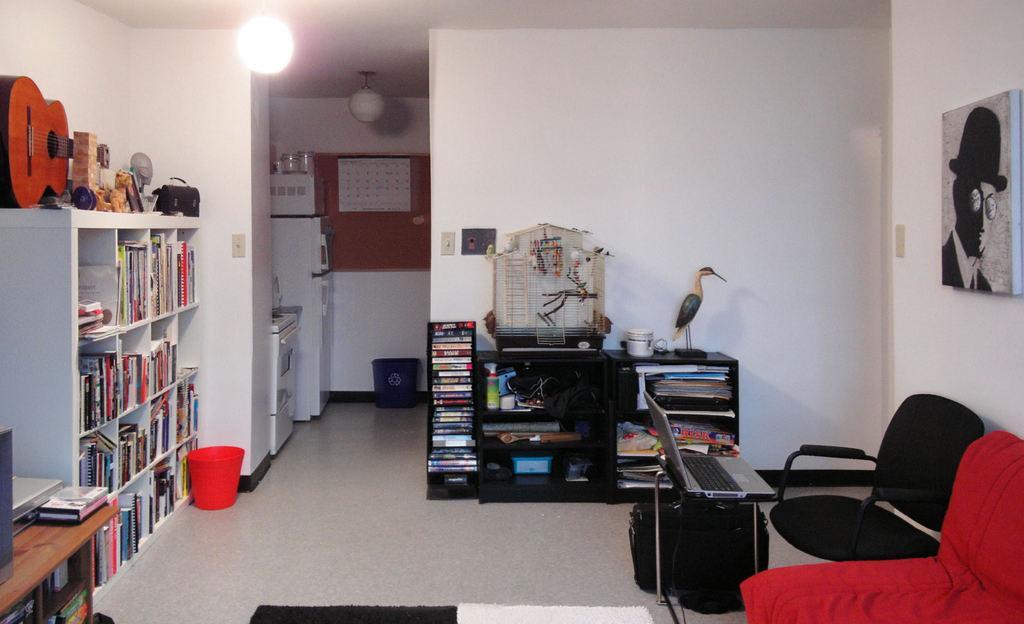Could you give a brief overview of what you see in this image? In this image there is a frame attached to the wall , books and some objects on the shelves and in the shelves, dustbins, guitar, washing machine , refrigerator, carpet, chairs, laptop on the table, toy bird, bird cage. 